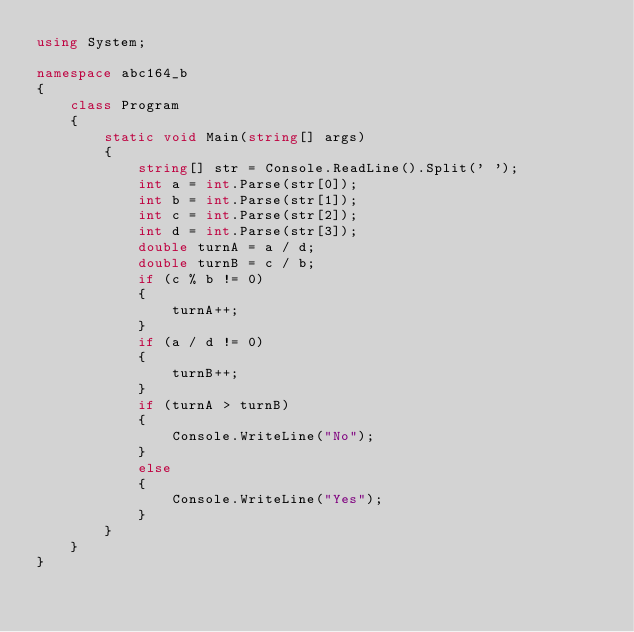<code> <loc_0><loc_0><loc_500><loc_500><_C#_>using System;

namespace abc164_b
{
    class Program
    {
        static void Main(string[] args)
        {
            string[] str = Console.ReadLine().Split(' ');
            int a = int.Parse(str[0]);
            int b = int.Parse(str[1]);
            int c = int.Parse(str[2]);
            int d = int.Parse(str[3]);
            double turnA = a / d;
            double turnB = c / b;
            if (c % b != 0)
            {
                turnA++;
            }
            if (a / d != 0)
            {
                turnB++;
            }
            if (turnA > turnB)
            {
                Console.WriteLine("No");
            }
            else
            {
                Console.WriteLine("Yes");
            }
        }
    }
}
</code> 